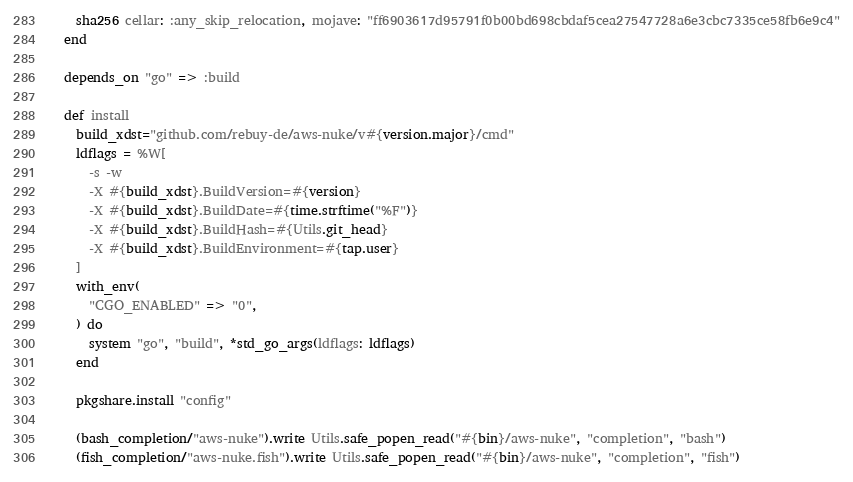<code> <loc_0><loc_0><loc_500><loc_500><_Ruby_>    sha256 cellar: :any_skip_relocation, mojave: "ff6903617d95791f0b00bd698cbdaf5cea27547728a6e3cbc7335ce58fb6e9c4"
  end

  depends_on "go" => :build

  def install
    build_xdst="github.com/rebuy-de/aws-nuke/v#{version.major}/cmd"
    ldflags = %W[
      -s -w
      -X #{build_xdst}.BuildVersion=#{version}
      -X #{build_xdst}.BuildDate=#{time.strftime("%F")}
      -X #{build_xdst}.BuildHash=#{Utils.git_head}
      -X #{build_xdst}.BuildEnvironment=#{tap.user}
    ]
    with_env(
      "CGO_ENABLED" => "0",
    ) do
      system "go", "build", *std_go_args(ldflags: ldflags)
    end

    pkgshare.install "config"

    (bash_completion/"aws-nuke").write Utils.safe_popen_read("#{bin}/aws-nuke", "completion", "bash")
    (fish_completion/"aws-nuke.fish").write Utils.safe_popen_read("#{bin}/aws-nuke", "completion", "fish")</code> 